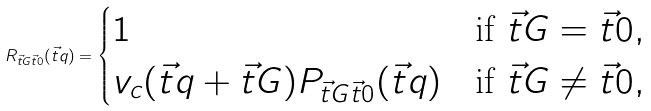Convert formula to latex. <formula><loc_0><loc_0><loc_500><loc_500>R _ { \vec { t } { G } \vec { t } { 0 } } ( \vec { t } { q } ) = \begin{cases} 1 & \text {if $\vec{t}{G} = \vec{t}{0}$} , \\ v _ { c } ( \vec { t } { q } + \vec { t } { G } ) P _ { \vec { t } { G } \vec { t } { 0 } } ( \vec { t } { q } ) & \text {if $\vec{t}{G} \ne \vec{t}{0}$} , \end{cases}</formula> 